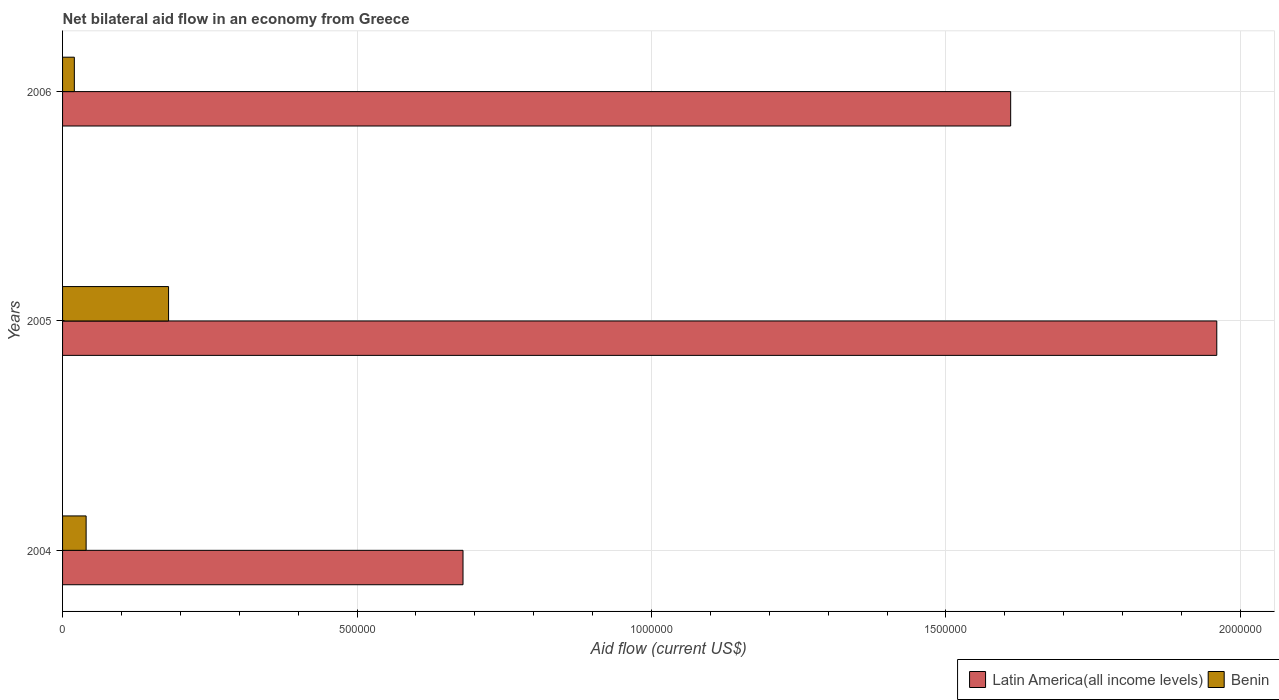Are the number of bars per tick equal to the number of legend labels?
Make the answer very short. Yes. Are the number of bars on each tick of the Y-axis equal?
Your answer should be very brief. Yes. How many bars are there on the 1st tick from the top?
Provide a short and direct response. 2. What is the label of the 2nd group of bars from the top?
Provide a succinct answer. 2005. What is the net bilateral aid flow in Latin America(all income levels) in 2004?
Offer a very short reply. 6.80e+05. In which year was the net bilateral aid flow in Latin America(all income levels) maximum?
Your answer should be very brief. 2005. What is the difference between the net bilateral aid flow in Benin in 2004 and that in 2006?
Offer a terse response. 2.00e+04. What is the difference between the net bilateral aid flow in Benin in 2006 and the net bilateral aid flow in Latin America(all income levels) in 2005?
Keep it short and to the point. -1.94e+06. What is the average net bilateral aid flow in Latin America(all income levels) per year?
Keep it short and to the point. 1.42e+06. In the year 2005, what is the difference between the net bilateral aid flow in Benin and net bilateral aid flow in Latin America(all income levels)?
Offer a very short reply. -1.78e+06. In how many years, is the net bilateral aid flow in Latin America(all income levels) greater than 1500000 US$?
Keep it short and to the point. 2. What is the ratio of the net bilateral aid flow in Benin in 2004 to that in 2006?
Keep it short and to the point. 2. Is the difference between the net bilateral aid flow in Benin in 2004 and 2005 greater than the difference between the net bilateral aid flow in Latin America(all income levels) in 2004 and 2005?
Your answer should be very brief. Yes. What is the difference between the highest and the lowest net bilateral aid flow in Benin?
Give a very brief answer. 1.60e+05. What does the 2nd bar from the top in 2004 represents?
Offer a terse response. Latin America(all income levels). What does the 1st bar from the bottom in 2005 represents?
Give a very brief answer. Latin America(all income levels). How many bars are there?
Offer a terse response. 6. How many years are there in the graph?
Make the answer very short. 3. What is the difference between two consecutive major ticks on the X-axis?
Keep it short and to the point. 5.00e+05. Are the values on the major ticks of X-axis written in scientific E-notation?
Make the answer very short. No. Does the graph contain any zero values?
Give a very brief answer. No. Where does the legend appear in the graph?
Keep it short and to the point. Bottom right. What is the title of the graph?
Make the answer very short. Net bilateral aid flow in an economy from Greece. What is the label or title of the Y-axis?
Your response must be concise. Years. What is the Aid flow (current US$) in Latin America(all income levels) in 2004?
Offer a very short reply. 6.80e+05. What is the Aid flow (current US$) in Latin America(all income levels) in 2005?
Provide a succinct answer. 1.96e+06. What is the Aid flow (current US$) of Latin America(all income levels) in 2006?
Give a very brief answer. 1.61e+06. Across all years, what is the maximum Aid flow (current US$) of Latin America(all income levels)?
Make the answer very short. 1.96e+06. Across all years, what is the minimum Aid flow (current US$) in Latin America(all income levels)?
Your response must be concise. 6.80e+05. Across all years, what is the minimum Aid flow (current US$) of Benin?
Provide a short and direct response. 2.00e+04. What is the total Aid flow (current US$) in Latin America(all income levels) in the graph?
Ensure brevity in your answer.  4.25e+06. What is the difference between the Aid flow (current US$) of Latin America(all income levels) in 2004 and that in 2005?
Offer a terse response. -1.28e+06. What is the difference between the Aid flow (current US$) in Benin in 2004 and that in 2005?
Give a very brief answer. -1.40e+05. What is the difference between the Aid flow (current US$) in Latin America(all income levels) in 2004 and that in 2006?
Your response must be concise. -9.30e+05. What is the difference between the Aid flow (current US$) of Benin in 2004 and that in 2006?
Give a very brief answer. 2.00e+04. What is the difference between the Aid flow (current US$) in Latin America(all income levels) in 2005 and that in 2006?
Your answer should be compact. 3.50e+05. What is the difference between the Aid flow (current US$) of Latin America(all income levels) in 2004 and the Aid flow (current US$) of Benin in 2006?
Your answer should be very brief. 6.60e+05. What is the difference between the Aid flow (current US$) in Latin America(all income levels) in 2005 and the Aid flow (current US$) in Benin in 2006?
Provide a succinct answer. 1.94e+06. What is the average Aid flow (current US$) of Latin America(all income levels) per year?
Make the answer very short. 1.42e+06. What is the average Aid flow (current US$) of Benin per year?
Ensure brevity in your answer.  8.00e+04. In the year 2004, what is the difference between the Aid flow (current US$) in Latin America(all income levels) and Aid flow (current US$) in Benin?
Keep it short and to the point. 6.40e+05. In the year 2005, what is the difference between the Aid flow (current US$) in Latin America(all income levels) and Aid flow (current US$) in Benin?
Offer a very short reply. 1.78e+06. In the year 2006, what is the difference between the Aid flow (current US$) in Latin America(all income levels) and Aid flow (current US$) in Benin?
Provide a succinct answer. 1.59e+06. What is the ratio of the Aid flow (current US$) in Latin America(all income levels) in 2004 to that in 2005?
Give a very brief answer. 0.35. What is the ratio of the Aid flow (current US$) of Benin in 2004 to that in 2005?
Your answer should be very brief. 0.22. What is the ratio of the Aid flow (current US$) in Latin America(all income levels) in 2004 to that in 2006?
Make the answer very short. 0.42. What is the ratio of the Aid flow (current US$) in Benin in 2004 to that in 2006?
Your answer should be compact. 2. What is the ratio of the Aid flow (current US$) of Latin America(all income levels) in 2005 to that in 2006?
Give a very brief answer. 1.22. What is the ratio of the Aid flow (current US$) of Benin in 2005 to that in 2006?
Give a very brief answer. 9. What is the difference between the highest and the second highest Aid flow (current US$) in Latin America(all income levels)?
Give a very brief answer. 3.50e+05. What is the difference between the highest and the lowest Aid flow (current US$) of Latin America(all income levels)?
Give a very brief answer. 1.28e+06. 